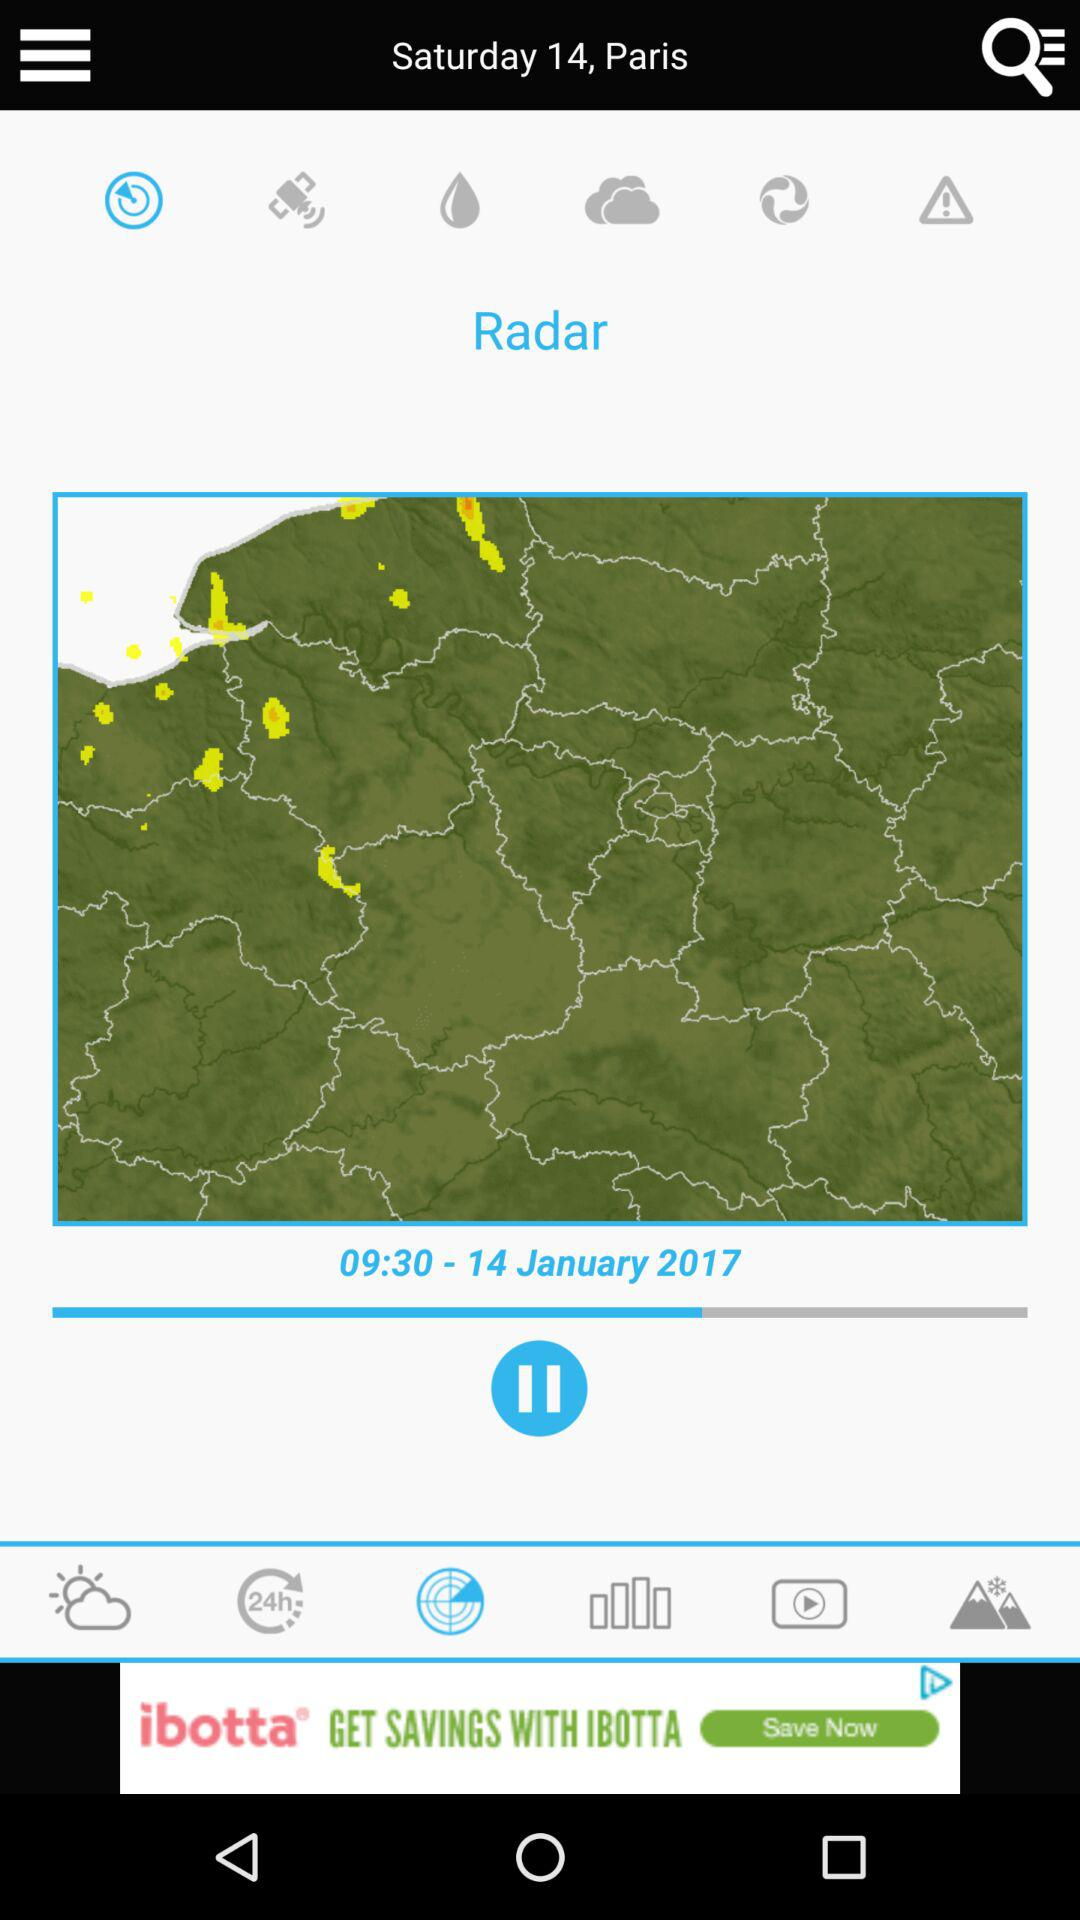Which tab is selected? The selected tab is "Radar". 